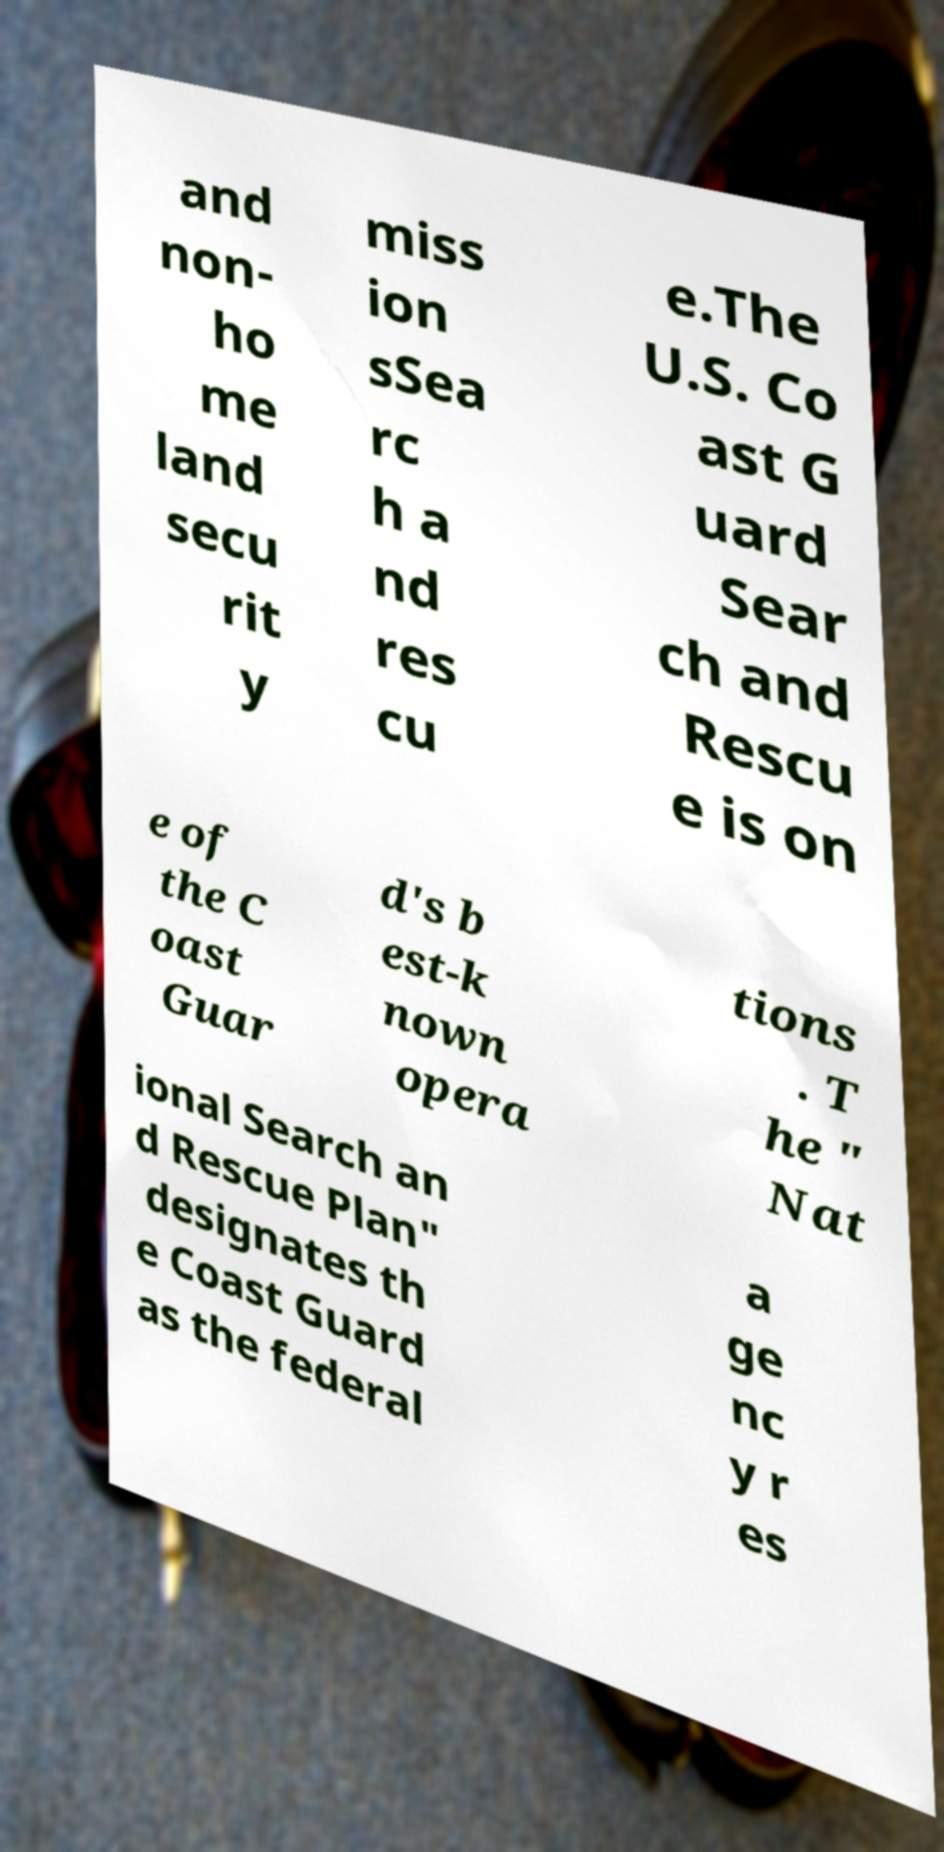What messages or text are displayed in this image? I need them in a readable, typed format. and non- ho me land secu rit y miss ion sSea rc h a nd res cu e.The U.S. Co ast G uard Sear ch and Rescu e is on e of the C oast Guar d's b est-k nown opera tions . T he " Nat ional Search an d Rescue Plan" designates th e Coast Guard as the federal a ge nc y r es 